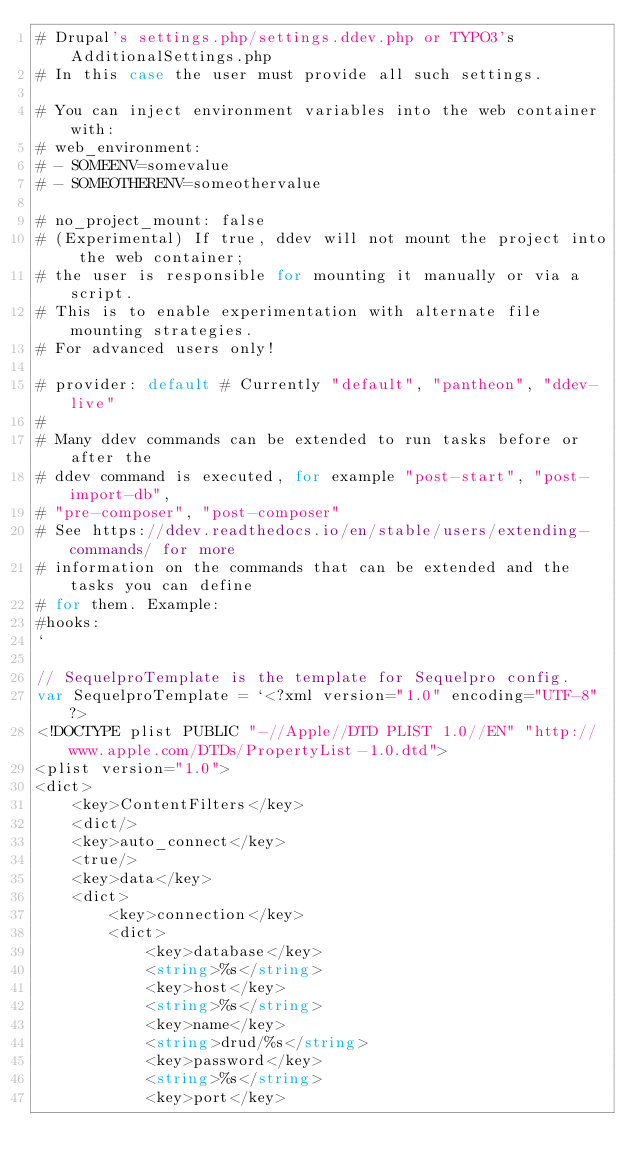Convert code to text. <code><loc_0><loc_0><loc_500><loc_500><_Go_># Drupal's settings.php/settings.ddev.php or TYPO3's AdditionalSettings.php
# In this case the user must provide all such settings.

# You can inject environment variables into the web container with:
# web_environment: 
# - SOMEENV=somevalue
# - SOMEOTHERENV=someothervalue

# no_project_mount: false
# (Experimental) If true, ddev will not mount the project into the web container;
# the user is responsible for mounting it manually or via a script.
# This is to enable experimentation with alternate file mounting strategies.
# For advanced users only!

# provider: default # Currently "default", "pantheon", "ddev-live"
# 
# Many ddev commands can be extended to run tasks before or after the
# ddev command is executed, for example "post-start", "post-import-db",
# "pre-composer", "post-composer"
# See https://ddev.readthedocs.io/en/stable/users/extending-commands/ for more
# information on the commands that can be extended and the tasks you can define
# for them. Example:
#hooks:
`

// SequelproTemplate is the template for Sequelpro config.
var SequelproTemplate = `<?xml version="1.0" encoding="UTF-8"?>
<!DOCTYPE plist PUBLIC "-//Apple//DTD PLIST 1.0//EN" "http://www.apple.com/DTDs/PropertyList-1.0.dtd">
<plist version="1.0">
<dict>
    <key>ContentFilters</key>
    <dict/>
    <key>auto_connect</key>
    <true/>
    <key>data</key>
    <dict>
        <key>connection</key>
        <dict>
            <key>database</key>
            <string>%s</string>
            <key>host</key>
            <string>%s</string>
            <key>name</key>
            <string>drud/%s</string>
            <key>password</key>
            <string>%s</string>
            <key>port</key></code> 